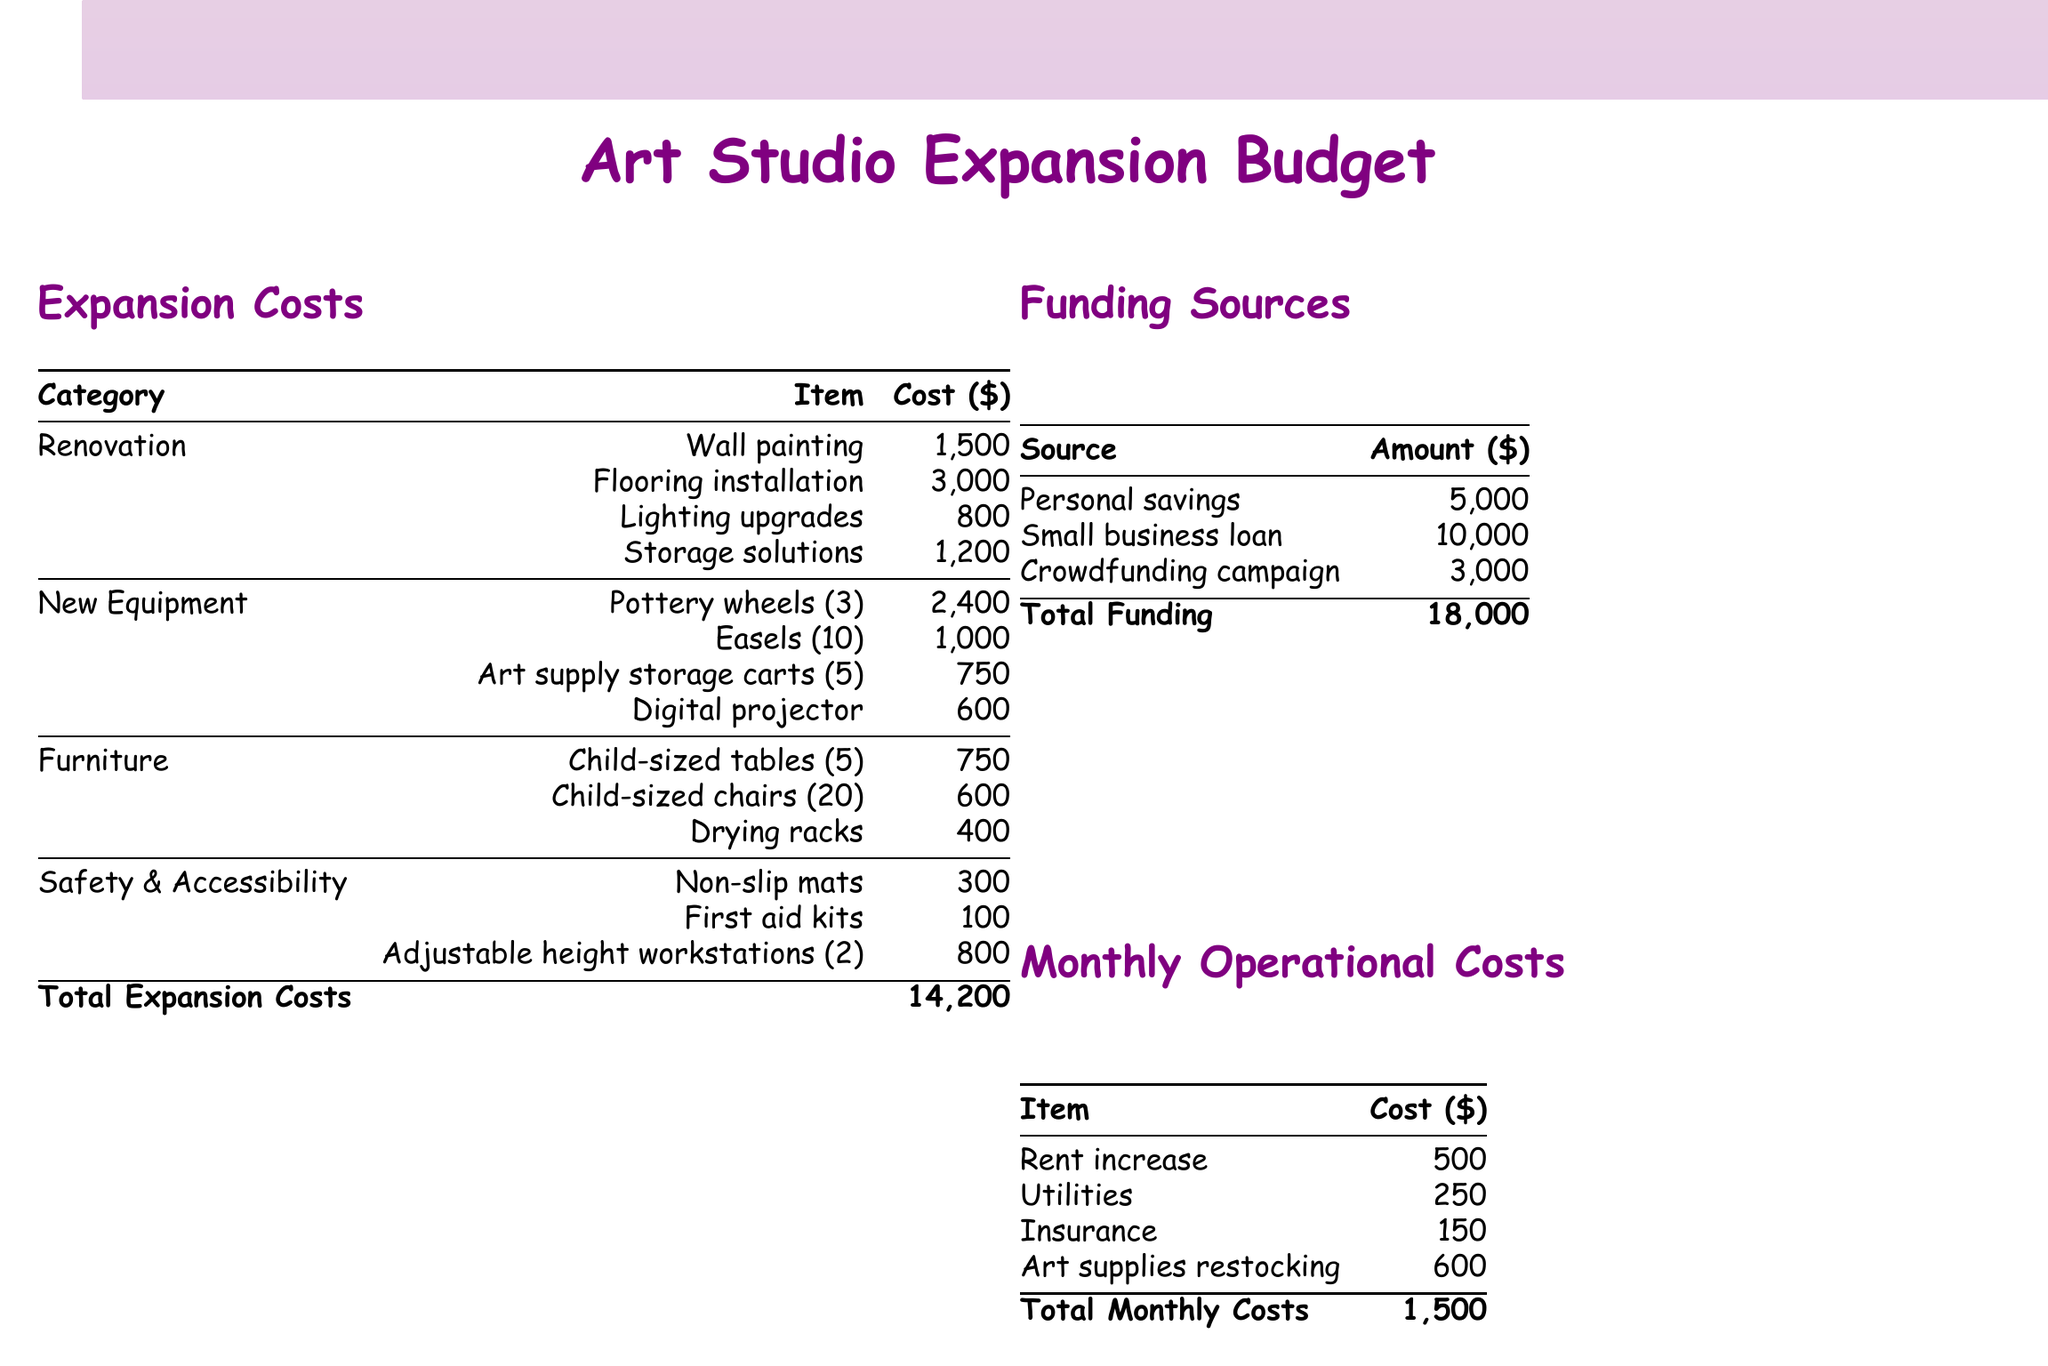what is the total cost of expansion? The total expansion costs are listed at the end of the expansion costs section, which sums all individual costs.
Answer: 14,200 how much is allocated for renovation? The renovation costs are specified in the expansion costs table, and they include multiple items that sum up to this category.
Answer: 6,500 how many pottery wheels are being purchased? The itemized section for new equipment states the number of pottery wheels being acquired.
Answer: 3 what is the amount collected from crowdfunding? The funding sources table indicates the dollar amount obtained through crowdfunding efforts.
Answer: 3,000 what are the monthly operational costs? The total monthly operational costs are calculated by summing up all the listed items in this category.
Answer: 1,500 how much will the rent increase by? The rent increase is a specific item listed in the monthly operational costs table, indicating the expected change.
Answer: 500 what is the price charged per student? The projected revenue section specifies the price set for each student attending a class.
Answer: 25 how many child-sized chairs will be purchased? The furniture section outlines how many child-sized chairs are included in the new purchases.
Answer: 20 what is the total funding amount? The total funding is the sum of all the sources listed in the funding sources table.
Answer: 18,000 